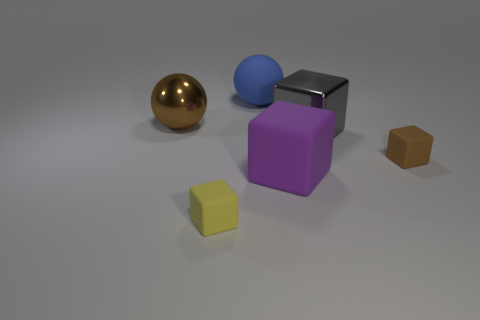How many big matte objects are both behind the metallic ball and right of the blue thing? In the image, there is one large matte object that fits the description: a purple cube. It is positioned both behind the metallic ball and to the right of the blue sphere. 